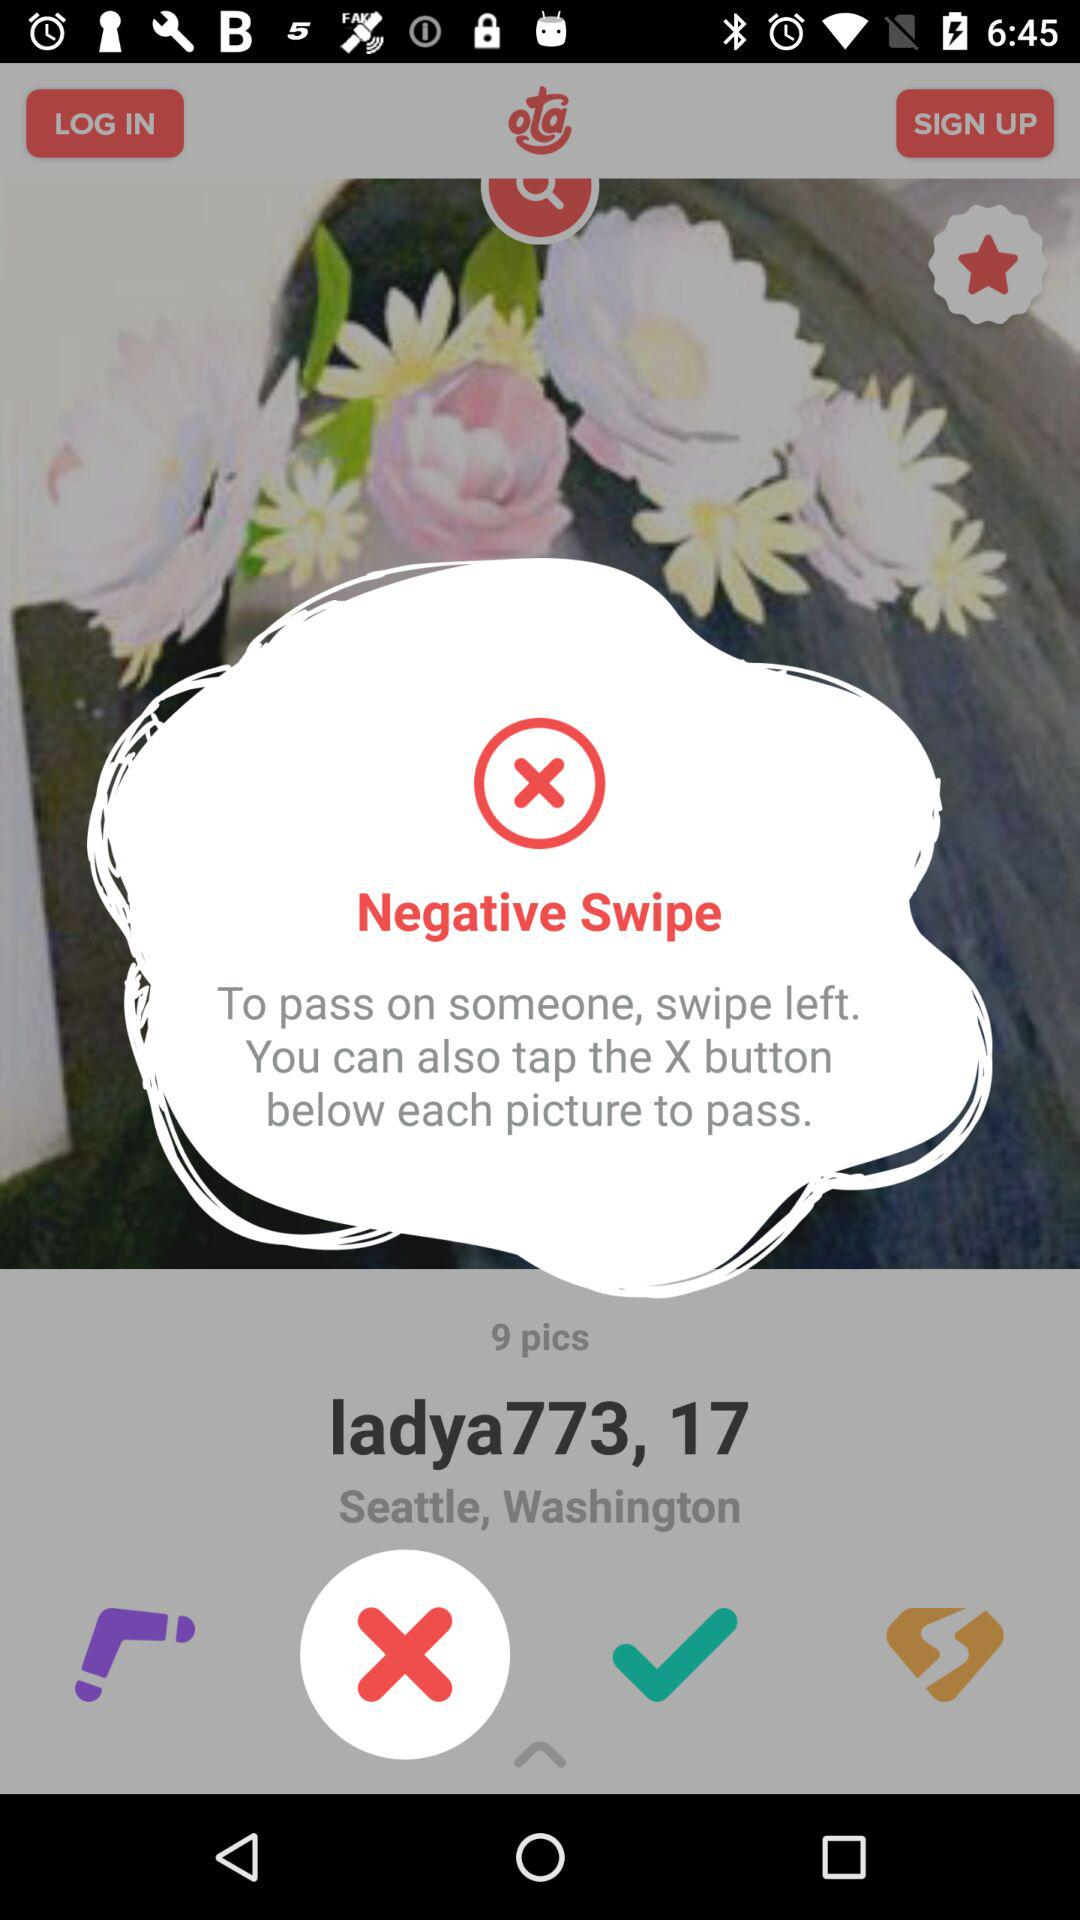What is the age of the user? The age of the user is 17. 